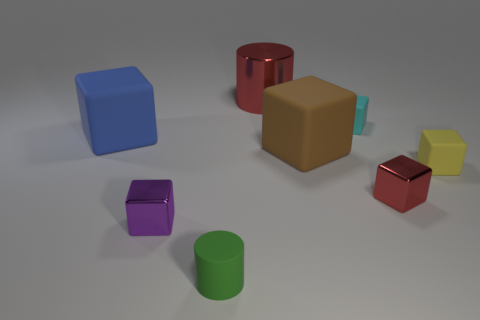Subtract all purple cubes. How many cubes are left? 5 Subtract all red cubes. How many cubes are left? 5 Subtract all cubes. How many objects are left? 2 Subtract 4 cubes. How many cubes are left? 2 Add 2 big rubber cubes. How many objects exist? 10 Subtract all purple cylinders. Subtract all brown balls. How many cylinders are left? 2 Subtract all large brown metallic spheres. Subtract all big brown cubes. How many objects are left? 7 Add 7 cyan cubes. How many cyan cubes are left? 8 Add 2 big matte things. How many big matte things exist? 4 Subtract 0 gray balls. How many objects are left? 8 